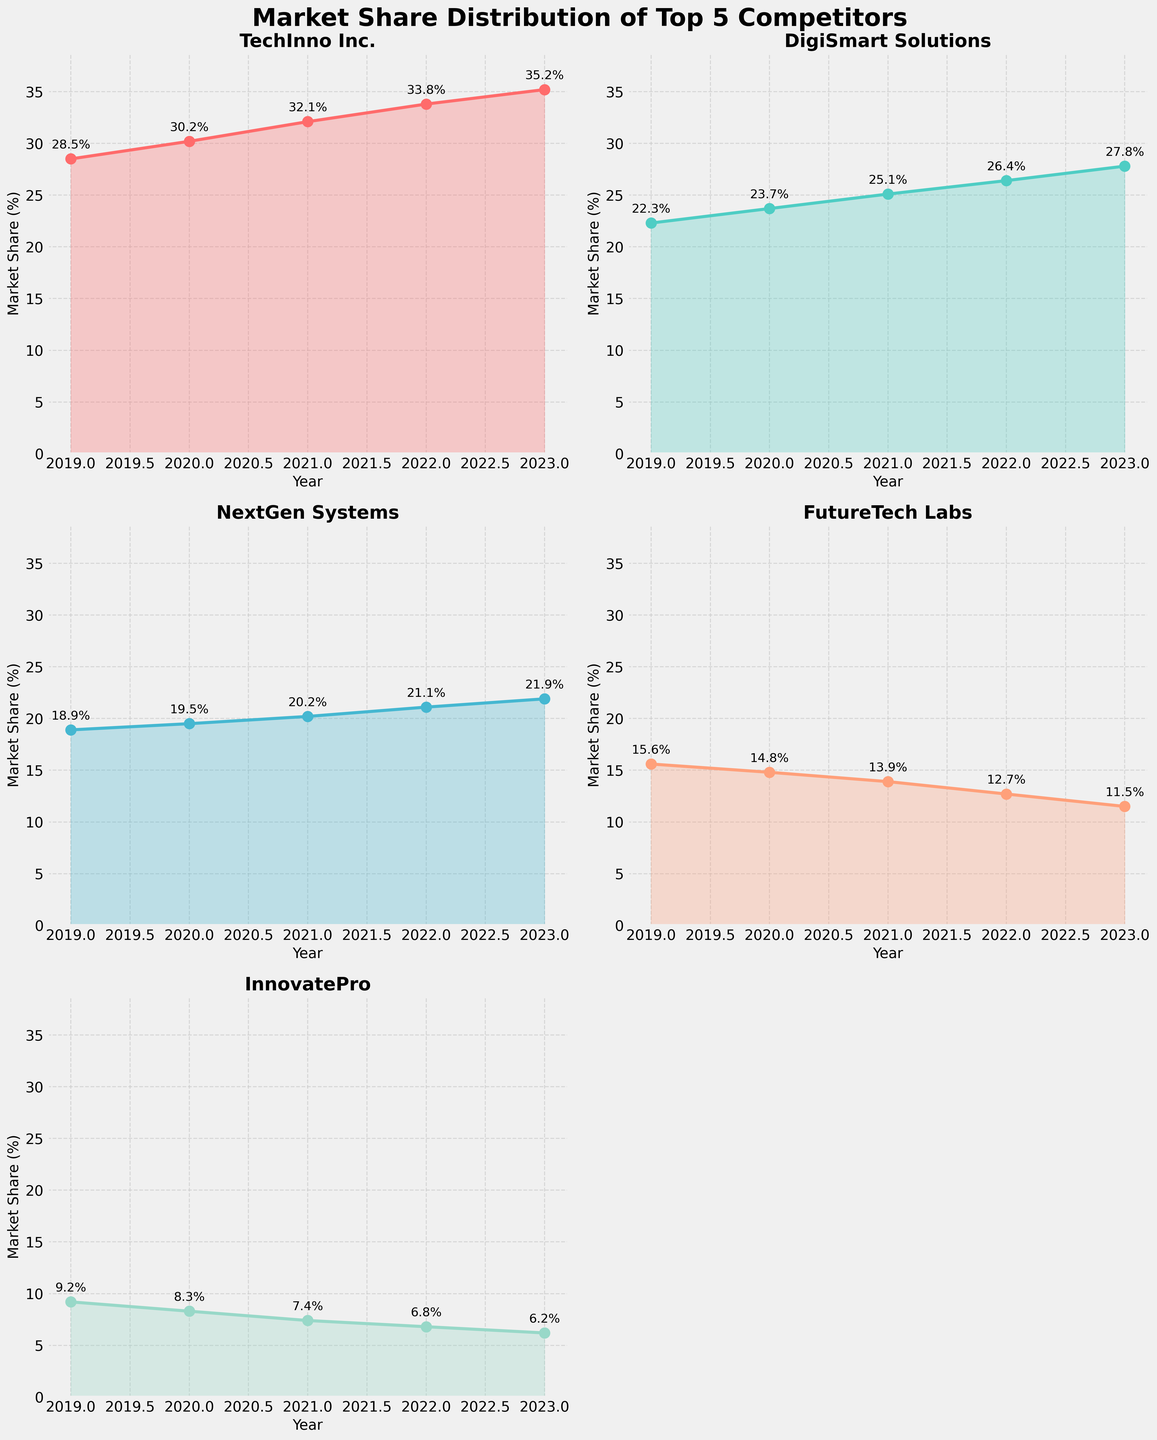What is the trend in market share for FutureTech Labs from 2019 to 2023? The plot for FutureTech Labs shows a consistent decline in market share from 15.6% in 2019 to 11.5% in 2023. Highlighting the years and corresponding values clearly depicts this downward trend.
Answer: Declining How does the market share of TechInno Inc. in 2023 compare to InnovatePro's market share in 2019? The plot for TechInno Inc. shows a market share of 35.2% in 2023, while InnovatePro's plot shows a market share of 9.2% in 2019. Comparing these values reveals that TechInno Inc. has a significantly higher market share in 2023 compared to InnovatePro in 2019.
Answer: TechInno Inc. is higher Which competitor had the smallest market share in 2022, and what was it? By looking at the plots for 2022, InnovatePro has the smallest market share at 6.8% as indicated next to the marker on the plot.
Answer: InnovatePro, 6.8% What is the average market share of DigiSmart Solutions over the five-year period? To find the average market share of DigiSmart Solutions, add up the values from 2019 to 2023 (22.3 + 23.7 + 25.1 + 26.4 + 27.8 = 125.3) and divide by 5.
Answer: 25.06% Compare the market share growth between TechInno Inc. and NextGen Systems from 2019 to 2023. Which one grew more and by how much? TechInno Inc. increased from 28.5% to 35.2%, a growth of 6.7%. NextGen Systems increased from 18.9% to 21.9%, a growth of 3%. Therefore, TechInno Inc. grew more by 3.7% (6.7% - 3%).
Answer: TechInno Inc. by 3.7% 